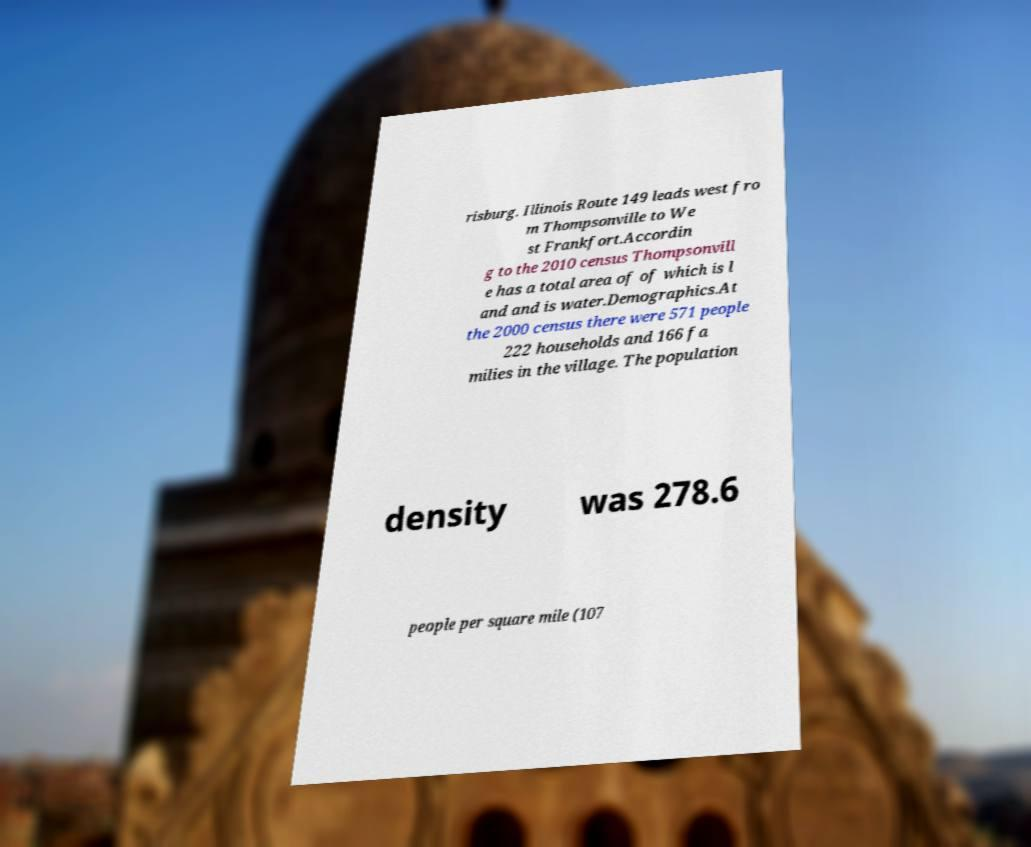Can you accurately transcribe the text from the provided image for me? risburg. Illinois Route 149 leads west fro m Thompsonville to We st Frankfort.Accordin g to the 2010 census Thompsonvill e has a total area of of which is l and and is water.Demographics.At the 2000 census there were 571 people 222 households and 166 fa milies in the village. The population density was 278.6 people per square mile (107 